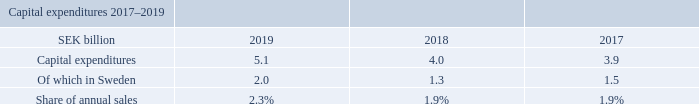Capital expenditures
For 2019, capital expenditure was SEK 5.1 (4.0) billion, representing 2.3% of sales. Expenditures are largely related to test sites and equipment for R&D, network operation centers and manufacturing and repair operations.
The increase in 2019 was mainly due to investments in 5G test equipment.
Annual capital expenditures are normally around 2% of sales. This corresponds to the needs for keeping and maintaining the current capacity level. The Board of Directors reviews the Company’s investment plans and proposals.
As of December 31, 2019, no material land, buildings, machinery or equipment were pledged as collateral for outstanding indebtedness.
What is the capital expenditure of 2017?
Answer scale should be: billion. 3.9. What has been pledged as collateral for outstanding indebtedness in 2019? No material land, buildings, machinery or equipment were pledged. Why was there an increase in capital expenditure in 2019? Investments in 5g test equipment. What is the change between capital expenditure in 2019 and 2018?
Answer scale should be: billion. 5.1-4.0
Answer: 1.1. What is the change in share of annual sales between 2018 and 2019?
Answer scale should be: percent. 2.3-1.9
Answer: 0.4. Which year has a higher capital expenditures? 5.1>4.0> 3.9
Answer: 2019. 